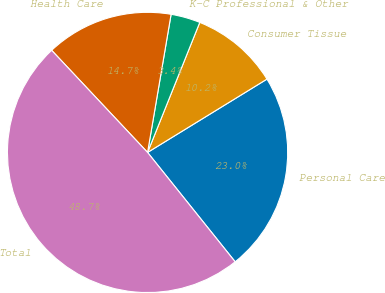Convert chart. <chart><loc_0><loc_0><loc_500><loc_500><pie_chart><fcel>Personal Care<fcel>Consumer Tissue<fcel>K-C Professional & Other<fcel>Health Care<fcel>Total<nl><fcel>23.02%<fcel>10.16%<fcel>3.39%<fcel>14.69%<fcel>48.75%<nl></chart> 